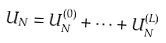Convert formula to latex. <formula><loc_0><loc_0><loc_500><loc_500>U _ { N } = U _ { N } ^ { ( 0 ) } + \dots + U _ { N } ^ { ( L ) }</formula> 